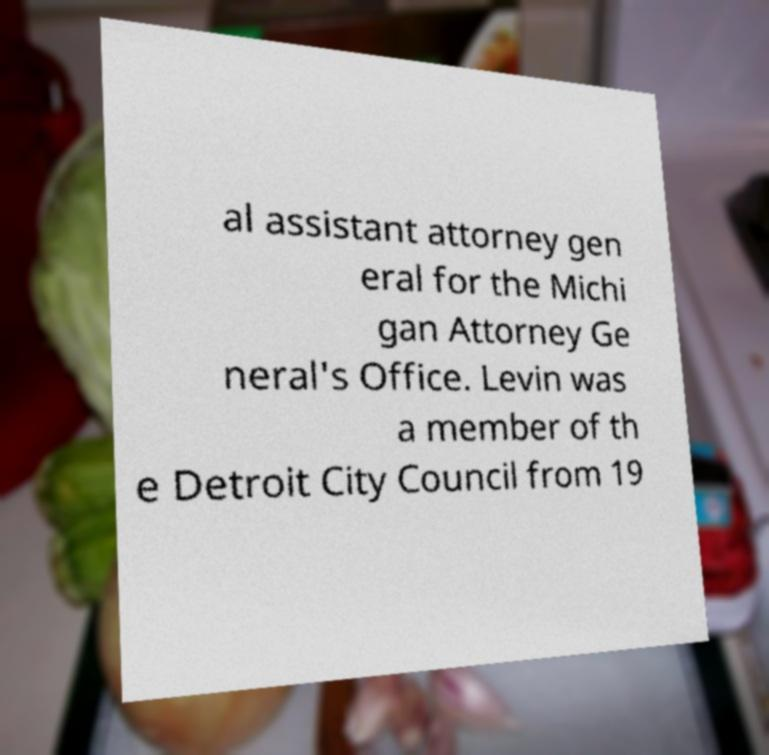There's text embedded in this image that I need extracted. Can you transcribe it verbatim? al assistant attorney gen eral for the Michi gan Attorney Ge neral's Office. Levin was a member of th e Detroit City Council from 19 